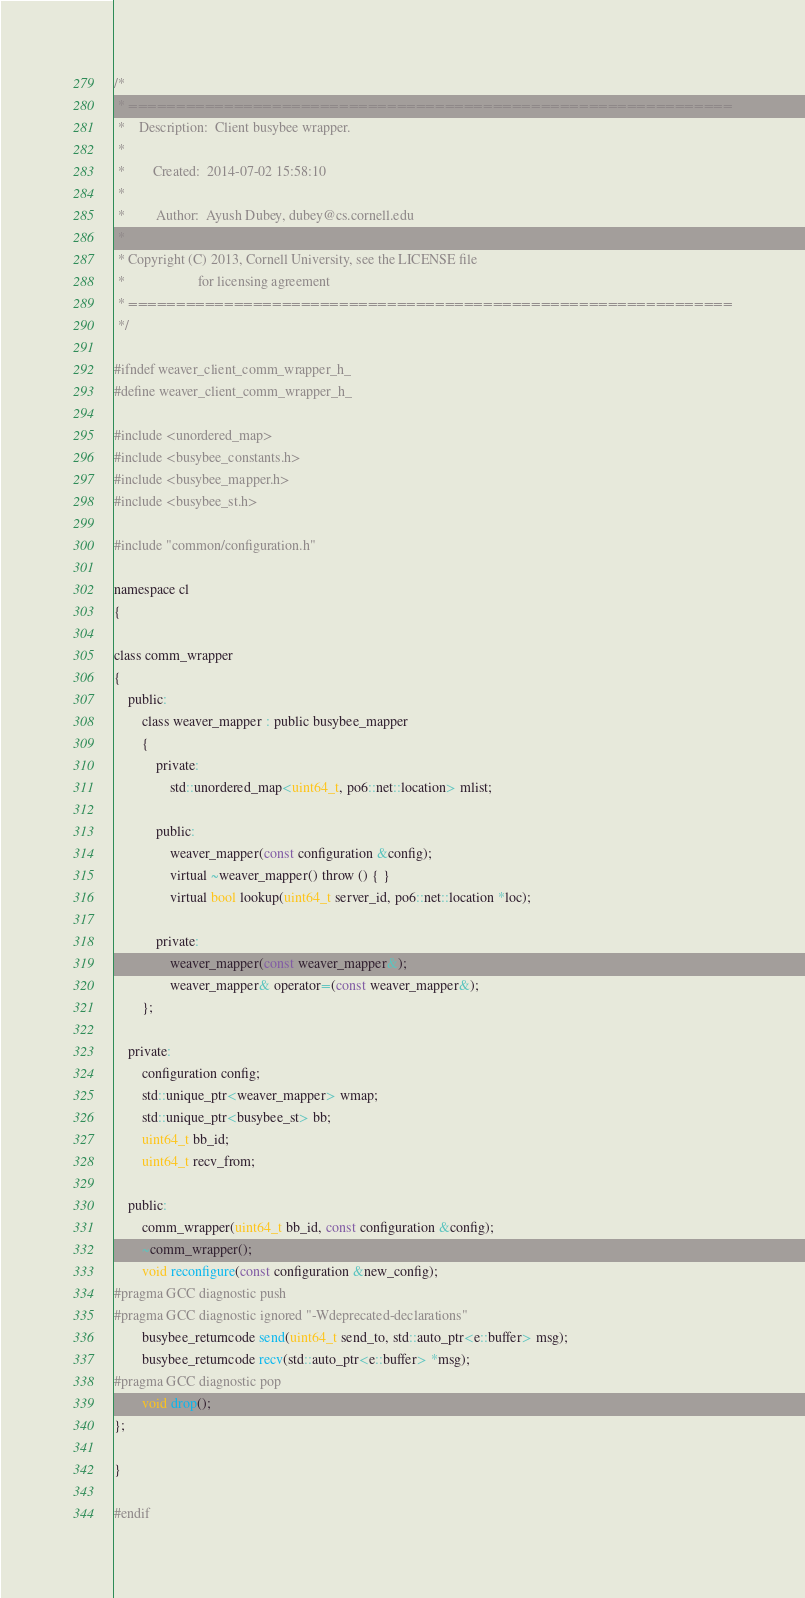Convert code to text. <code><loc_0><loc_0><loc_500><loc_500><_C_>/*
 * ===============================================================
 *    Description:  Client busybee wrapper.
 *
 *        Created:  2014-07-02 15:58:10
 *
 *         Author:  Ayush Dubey, dubey@cs.cornell.edu
 *
 * Copyright (C) 2013, Cornell University, see the LICENSE file
 *                     for licensing agreement
 * ===============================================================
 */

#ifndef weaver_client_comm_wrapper_h_
#define weaver_client_comm_wrapper_h_

#include <unordered_map>
#include <busybee_constants.h>
#include <busybee_mapper.h>
#include <busybee_st.h>

#include "common/configuration.h"

namespace cl
{

class comm_wrapper
{
    public:
        class weaver_mapper : public busybee_mapper
        {
            private:
                std::unordered_map<uint64_t, po6::net::location> mlist;

            public:
                weaver_mapper(const configuration &config);
                virtual ~weaver_mapper() throw () { }
                virtual bool lookup(uint64_t server_id, po6::net::location *loc);

            private:
                weaver_mapper(const weaver_mapper&);
                weaver_mapper& operator=(const weaver_mapper&);
        };

    private:
        configuration config;
        std::unique_ptr<weaver_mapper> wmap;
        std::unique_ptr<busybee_st> bb;
        uint64_t bb_id;
        uint64_t recv_from;

    public:
        comm_wrapper(uint64_t bb_id, const configuration &config);
        ~comm_wrapper();
        void reconfigure(const configuration &new_config);
#pragma GCC diagnostic push
#pragma GCC diagnostic ignored "-Wdeprecated-declarations"
        busybee_returncode send(uint64_t send_to, std::auto_ptr<e::buffer> msg);
        busybee_returncode recv(std::auto_ptr<e::buffer> *msg);
#pragma GCC diagnostic pop
        void drop();
};

}

#endif
</code> 